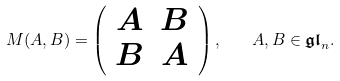<formula> <loc_0><loc_0><loc_500><loc_500>M ( A , B ) = \left ( \begin{array} { c c } A & B \\ B & A \end{array} \right ) , \quad A , B \in \mathfrak { g l } _ { n } .</formula> 